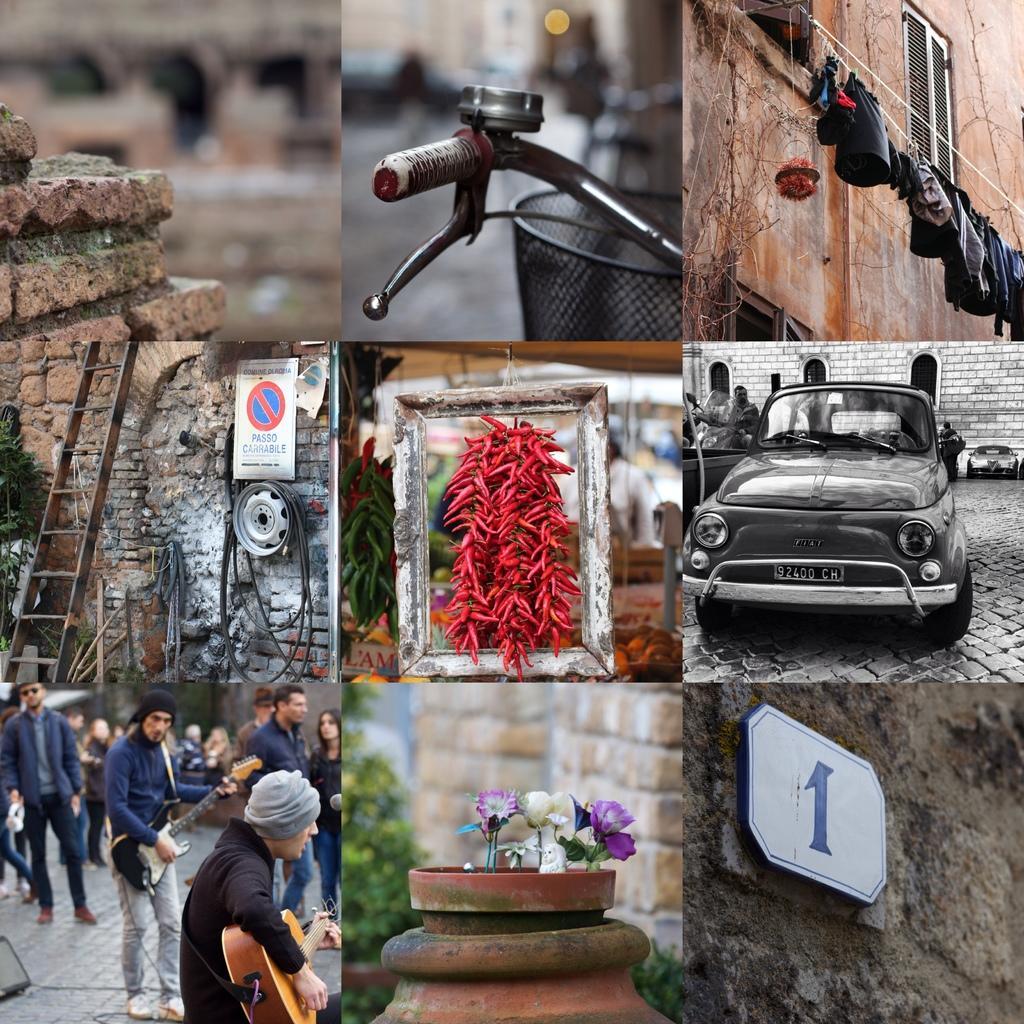How would you summarize this image in a sentence or two? In this picture there are multiple pictures. In one picture we can see cycle bell. And some clothes are hanging. A car, ladder and some people are playing guitar. Flower pot and a number board. 